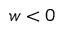Convert formula to latex. <formula><loc_0><loc_0><loc_500><loc_500>w < 0</formula> 